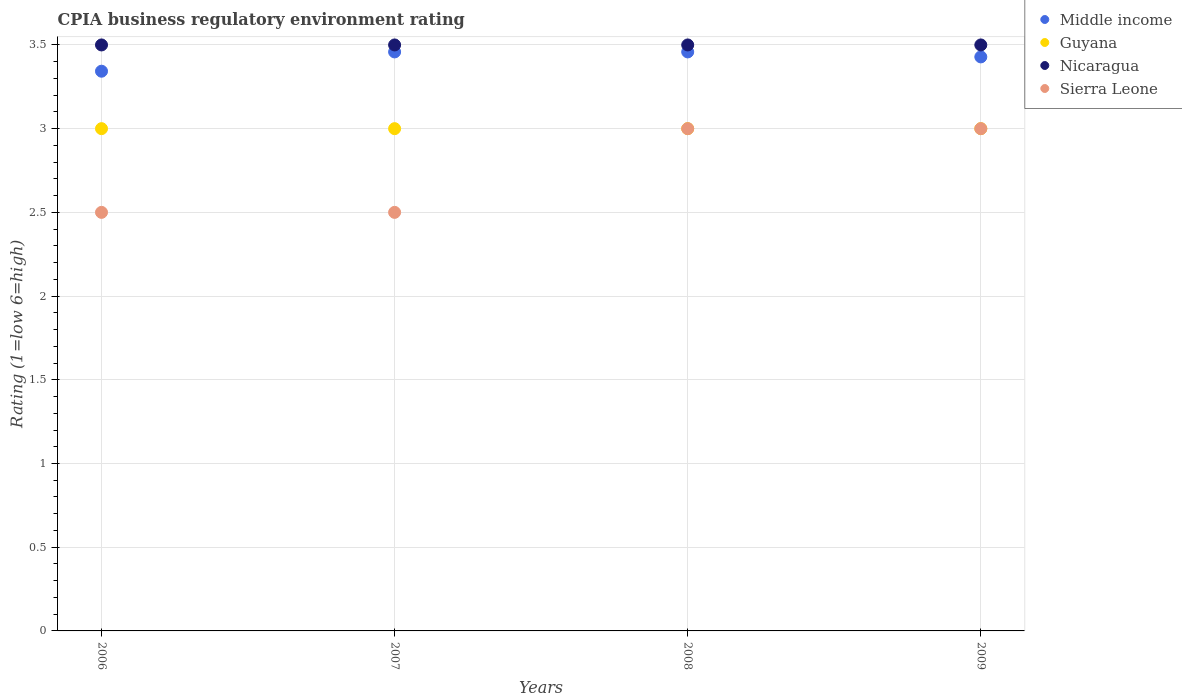How many different coloured dotlines are there?
Offer a very short reply. 4. Across all years, what is the maximum CPIA rating in Guyana?
Your answer should be compact. 3. In which year was the CPIA rating in Middle income maximum?
Ensure brevity in your answer.  2007. In which year was the CPIA rating in Guyana minimum?
Give a very brief answer. 2006. What is the total CPIA rating in Sierra Leone in the graph?
Your response must be concise. 11. What is the difference between the CPIA rating in Middle income in 2006 and the CPIA rating in Nicaragua in 2009?
Provide a succinct answer. -0.16. What is the average CPIA rating in Sierra Leone per year?
Provide a short and direct response. 2.75. In the year 2008, what is the difference between the CPIA rating in Nicaragua and CPIA rating in Sierra Leone?
Ensure brevity in your answer.  0.5. What is the ratio of the CPIA rating in Guyana in 2007 to that in 2008?
Make the answer very short. 1. Is the CPIA rating in Guyana in 2008 less than that in 2009?
Give a very brief answer. No. Is the difference between the CPIA rating in Nicaragua in 2008 and 2009 greater than the difference between the CPIA rating in Sierra Leone in 2008 and 2009?
Your answer should be very brief. No. What is the difference between the highest and the lowest CPIA rating in Nicaragua?
Your answer should be very brief. 0. Is the sum of the CPIA rating in Nicaragua in 2006 and 2009 greater than the maximum CPIA rating in Guyana across all years?
Provide a succinct answer. Yes. Is it the case that in every year, the sum of the CPIA rating in Middle income and CPIA rating in Nicaragua  is greater than the sum of CPIA rating in Sierra Leone and CPIA rating in Guyana?
Keep it short and to the point. Yes. Is it the case that in every year, the sum of the CPIA rating in Sierra Leone and CPIA rating in Nicaragua  is greater than the CPIA rating in Middle income?
Ensure brevity in your answer.  Yes. Does the CPIA rating in Guyana monotonically increase over the years?
Ensure brevity in your answer.  No. Is the CPIA rating in Guyana strictly greater than the CPIA rating in Sierra Leone over the years?
Ensure brevity in your answer.  No. How many years are there in the graph?
Your answer should be very brief. 4. Does the graph contain any zero values?
Keep it short and to the point. No. Where does the legend appear in the graph?
Provide a succinct answer. Top right. What is the title of the graph?
Keep it short and to the point. CPIA business regulatory environment rating. What is the label or title of the X-axis?
Provide a short and direct response. Years. What is the Rating (1=low 6=high) in Middle income in 2006?
Give a very brief answer. 3.34. What is the Rating (1=low 6=high) of Guyana in 2006?
Your answer should be compact. 3. What is the Rating (1=low 6=high) in Middle income in 2007?
Provide a short and direct response. 3.46. What is the Rating (1=low 6=high) of Middle income in 2008?
Ensure brevity in your answer.  3.46. What is the Rating (1=low 6=high) of Guyana in 2008?
Give a very brief answer. 3. What is the Rating (1=low 6=high) of Nicaragua in 2008?
Your answer should be very brief. 3.5. What is the Rating (1=low 6=high) of Middle income in 2009?
Ensure brevity in your answer.  3.43. What is the Rating (1=low 6=high) in Guyana in 2009?
Ensure brevity in your answer.  3. Across all years, what is the maximum Rating (1=low 6=high) of Middle income?
Keep it short and to the point. 3.46. Across all years, what is the maximum Rating (1=low 6=high) of Guyana?
Your answer should be compact. 3. Across all years, what is the maximum Rating (1=low 6=high) of Sierra Leone?
Your answer should be very brief. 3. Across all years, what is the minimum Rating (1=low 6=high) in Middle income?
Ensure brevity in your answer.  3.34. Across all years, what is the minimum Rating (1=low 6=high) in Guyana?
Ensure brevity in your answer.  3. Across all years, what is the minimum Rating (1=low 6=high) of Nicaragua?
Your answer should be compact. 3.5. What is the total Rating (1=low 6=high) of Middle income in the graph?
Your answer should be compact. 13.69. What is the total Rating (1=low 6=high) of Guyana in the graph?
Your response must be concise. 12. What is the difference between the Rating (1=low 6=high) in Middle income in 2006 and that in 2007?
Keep it short and to the point. -0.12. What is the difference between the Rating (1=low 6=high) in Guyana in 2006 and that in 2007?
Your response must be concise. 0. What is the difference between the Rating (1=low 6=high) in Nicaragua in 2006 and that in 2007?
Your answer should be very brief. 0. What is the difference between the Rating (1=low 6=high) in Middle income in 2006 and that in 2008?
Offer a terse response. -0.12. What is the difference between the Rating (1=low 6=high) in Guyana in 2006 and that in 2008?
Offer a terse response. 0. What is the difference between the Rating (1=low 6=high) of Middle income in 2006 and that in 2009?
Make the answer very short. -0.09. What is the difference between the Rating (1=low 6=high) of Guyana in 2006 and that in 2009?
Ensure brevity in your answer.  0. What is the difference between the Rating (1=low 6=high) in Middle income in 2007 and that in 2008?
Provide a short and direct response. 0. What is the difference between the Rating (1=low 6=high) of Sierra Leone in 2007 and that in 2008?
Your response must be concise. -0.5. What is the difference between the Rating (1=low 6=high) in Middle income in 2007 and that in 2009?
Offer a terse response. 0.03. What is the difference between the Rating (1=low 6=high) of Guyana in 2007 and that in 2009?
Ensure brevity in your answer.  0. What is the difference between the Rating (1=low 6=high) of Middle income in 2008 and that in 2009?
Your answer should be compact. 0.03. What is the difference between the Rating (1=low 6=high) in Guyana in 2008 and that in 2009?
Offer a terse response. 0. What is the difference between the Rating (1=low 6=high) of Middle income in 2006 and the Rating (1=low 6=high) of Guyana in 2007?
Provide a short and direct response. 0.34. What is the difference between the Rating (1=low 6=high) of Middle income in 2006 and the Rating (1=low 6=high) of Nicaragua in 2007?
Your answer should be very brief. -0.16. What is the difference between the Rating (1=low 6=high) of Middle income in 2006 and the Rating (1=low 6=high) of Sierra Leone in 2007?
Your answer should be compact. 0.84. What is the difference between the Rating (1=low 6=high) in Guyana in 2006 and the Rating (1=low 6=high) in Nicaragua in 2007?
Give a very brief answer. -0.5. What is the difference between the Rating (1=low 6=high) in Nicaragua in 2006 and the Rating (1=low 6=high) in Sierra Leone in 2007?
Your answer should be very brief. 1. What is the difference between the Rating (1=low 6=high) in Middle income in 2006 and the Rating (1=low 6=high) in Guyana in 2008?
Provide a succinct answer. 0.34. What is the difference between the Rating (1=low 6=high) in Middle income in 2006 and the Rating (1=low 6=high) in Nicaragua in 2008?
Ensure brevity in your answer.  -0.16. What is the difference between the Rating (1=low 6=high) of Middle income in 2006 and the Rating (1=low 6=high) of Sierra Leone in 2008?
Keep it short and to the point. 0.34. What is the difference between the Rating (1=low 6=high) of Guyana in 2006 and the Rating (1=low 6=high) of Nicaragua in 2008?
Provide a succinct answer. -0.5. What is the difference between the Rating (1=low 6=high) of Nicaragua in 2006 and the Rating (1=low 6=high) of Sierra Leone in 2008?
Your answer should be compact. 0.5. What is the difference between the Rating (1=low 6=high) in Middle income in 2006 and the Rating (1=low 6=high) in Guyana in 2009?
Make the answer very short. 0.34. What is the difference between the Rating (1=low 6=high) of Middle income in 2006 and the Rating (1=low 6=high) of Nicaragua in 2009?
Make the answer very short. -0.16. What is the difference between the Rating (1=low 6=high) in Middle income in 2006 and the Rating (1=low 6=high) in Sierra Leone in 2009?
Your answer should be very brief. 0.34. What is the difference between the Rating (1=low 6=high) in Guyana in 2006 and the Rating (1=low 6=high) in Sierra Leone in 2009?
Provide a succinct answer. 0. What is the difference between the Rating (1=low 6=high) in Middle income in 2007 and the Rating (1=low 6=high) in Guyana in 2008?
Keep it short and to the point. 0.46. What is the difference between the Rating (1=low 6=high) of Middle income in 2007 and the Rating (1=low 6=high) of Nicaragua in 2008?
Make the answer very short. -0.04. What is the difference between the Rating (1=low 6=high) in Middle income in 2007 and the Rating (1=low 6=high) in Sierra Leone in 2008?
Your response must be concise. 0.46. What is the difference between the Rating (1=low 6=high) in Guyana in 2007 and the Rating (1=low 6=high) in Nicaragua in 2008?
Give a very brief answer. -0.5. What is the difference between the Rating (1=low 6=high) in Middle income in 2007 and the Rating (1=low 6=high) in Guyana in 2009?
Offer a very short reply. 0.46. What is the difference between the Rating (1=low 6=high) of Middle income in 2007 and the Rating (1=low 6=high) of Nicaragua in 2009?
Provide a succinct answer. -0.04. What is the difference between the Rating (1=low 6=high) in Middle income in 2007 and the Rating (1=low 6=high) in Sierra Leone in 2009?
Give a very brief answer. 0.46. What is the difference between the Rating (1=low 6=high) in Guyana in 2007 and the Rating (1=low 6=high) in Nicaragua in 2009?
Give a very brief answer. -0.5. What is the difference between the Rating (1=low 6=high) in Guyana in 2007 and the Rating (1=low 6=high) in Sierra Leone in 2009?
Ensure brevity in your answer.  0. What is the difference between the Rating (1=low 6=high) of Nicaragua in 2007 and the Rating (1=low 6=high) of Sierra Leone in 2009?
Give a very brief answer. 0.5. What is the difference between the Rating (1=low 6=high) in Middle income in 2008 and the Rating (1=low 6=high) in Guyana in 2009?
Provide a succinct answer. 0.46. What is the difference between the Rating (1=low 6=high) of Middle income in 2008 and the Rating (1=low 6=high) of Nicaragua in 2009?
Provide a short and direct response. -0.04. What is the difference between the Rating (1=low 6=high) of Middle income in 2008 and the Rating (1=low 6=high) of Sierra Leone in 2009?
Keep it short and to the point. 0.46. What is the difference between the Rating (1=low 6=high) of Nicaragua in 2008 and the Rating (1=low 6=high) of Sierra Leone in 2009?
Ensure brevity in your answer.  0.5. What is the average Rating (1=low 6=high) of Middle income per year?
Offer a very short reply. 3.42. What is the average Rating (1=low 6=high) of Guyana per year?
Make the answer very short. 3. What is the average Rating (1=low 6=high) of Nicaragua per year?
Provide a short and direct response. 3.5. What is the average Rating (1=low 6=high) in Sierra Leone per year?
Keep it short and to the point. 2.75. In the year 2006, what is the difference between the Rating (1=low 6=high) of Middle income and Rating (1=low 6=high) of Guyana?
Your answer should be compact. 0.34. In the year 2006, what is the difference between the Rating (1=low 6=high) of Middle income and Rating (1=low 6=high) of Nicaragua?
Offer a very short reply. -0.16. In the year 2006, what is the difference between the Rating (1=low 6=high) of Middle income and Rating (1=low 6=high) of Sierra Leone?
Ensure brevity in your answer.  0.84. In the year 2006, what is the difference between the Rating (1=low 6=high) of Nicaragua and Rating (1=low 6=high) of Sierra Leone?
Your answer should be compact. 1. In the year 2007, what is the difference between the Rating (1=low 6=high) of Middle income and Rating (1=low 6=high) of Guyana?
Keep it short and to the point. 0.46. In the year 2007, what is the difference between the Rating (1=low 6=high) of Middle income and Rating (1=low 6=high) of Nicaragua?
Offer a terse response. -0.04. In the year 2007, what is the difference between the Rating (1=low 6=high) in Middle income and Rating (1=low 6=high) in Sierra Leone?
Keep it short and to the point. 0.96. In the year 2007, what is the difference between the Rating (1=low 6=high) in Nicaragua and Rating (1=low 6=high) in Sierra Leone?
Ensure brevity in your answer.  1. In the year 2008, what is the difference between the Rating (1=low 6=high) in Middle income and Rating (1=low 6=high) in Guyana?
Your answer should be very brief. 0.46. In the year 2008, what is the difference between the Rating (1=low 6=high) of Middle income and Rating (1=low 6=high) of Nicaragua?
Your answer should be very brief. -0.04. In the year 2008, what is the difference between the Rating (1=low 6=high) of Middle income and Rating (1=low 6=high) of Sierra Leone?
Offer a terse response. 0.46. In the year 2008, what is the difference between the Rating (1=low 6=high) of Guyana and Rating (1=low 6=high) of Nicaragua?
Your answer should be very brief. -0.5. In the year 2009, what is the difference between the Rating (1=low 6=high) in Middle income and Rating (1=low 6=high) in Guyana?
Your answer should be compact. 0.43. In the year 2009, what is the difference between the Rating (1=low 6=high) in Middle income and Rating (1=low 6=high) in Nicaragua?
Keep it short and to the point. -0.07. In the year 2009, what is the difference between the Rating (1=low 6=high) in Middle income and Rating (1=low 6=high) in Sierra Leone?
Make the answer very short. 0.43. In the year 2009, what is the difference between the Rating (1=low 6=high) in Guyana and Rating (1=low 6=high) in Nicaragua?
Provide a short and direct response. -0.5. In the year 2009, what is the difference between the Rating (1=low 6=high) in Guyana and Rating (1=low 6=high) in Sierra Leone?
Your answer should be very brief. 0. In the year 2009, what is the difference between the Rating (1=low 6=high) in Nicaragua and Rating (1=low 6=high) in Sierra Leone?
Offer a very short reply. 0.5. What is the ratio of the Rating (1=low 6=high) of Middle income in 2006 to that in 2007?
Provide a succinct answer. 0.97. What is the ratio of the Rating (1=low 6=high) in Guyana in 2006 to that in 2007?
Ensure brevity in your answer.  1. What is the ratio of the Rating (1=low 6=high) in Middle income in 2006 to that in 2008?
Make the answer very short. 0.97. What is the ratio of the Rating (1=low 6=high) in Sierra Leone in 2006 to that in 2008?
Your answer should be very brief. 0.83. What is the ratio of the Rating (1=low 6=high) of Middle income in 2006 to that in 2009?
Offer a very short reply. 0.98. What is the ratio of the Rating (1=low 6=high) in Sierra Leone in 2006 to that in 2009?
Provide a short and direct response. 0.83. What is the ratio of the Rating (1=low 6=high) of Middle income in 2007 to that in 2008?
Offer a very short reply. 1. What is the ratio of the Rating (1=low 6=high) in Guyana in 2007 to that in 2008?
Give a very brief answer. 1. What is the ratio of the Rating (1=low 6=high) of Sierra Leone in 2007 to that in 2008?
Your response must be concise. 0.83. What is the ratio of the Rating (1=low 6=high) of Middle income in 2007 to that in 2009?
Offer a very short reply. 1.01. What is the ratio of the Rating (1=low 6=high) in Guyana in 2007 to that in 2009?
Your answer should be compact. 1. What is the ratio of the Rating (1=low 6=high) in Middle income in 2008 to that in 2009?
Offer a terse response. 1.01. What is the ratio of the Rating (1=low 6=high) of Guyana in 2008 to that in 2009?
Provide a short and direct response. 1. What is the ratio of the Rating (1=low 6=high) of Nicaragua in 2008 to that in 2009?
Offer a very short reply. 1. What is the ratio of the Rating (1=low 6=high) in Sierra Leone in 2008 to that in 2009?
Your answer should be very brief. 1. What is the difference between the highest and the second highest Rating (1=low 6=high) of Middle income?
Ensure brevity in your answer.  0. What is the difference between the highest and the second highest Rating (1=low 6=high) in Guyana?
Your answer should be very brief. 0. What is the difference between the highest and the lowest Rating (1=low 6=high) of Middle income?
Your answer should be very brief. 0.12. What is the difference between the highest and the lowest Rating (1=low 6=high) in Guyana?
Your response must be concise. 0. What is the difference between the highest and the lowest Rating (1=low 6=high) in Nicaragua?
Your answer should be compact. 0. 